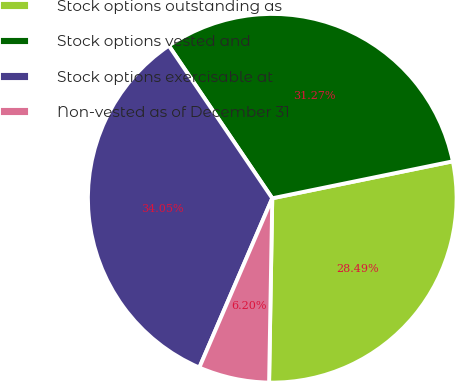Convert chart. <chart><loc_0><loc_0><loc_500><loc_500><pie_chart><fcel>Stock options outstanding as<fcel>Stock options vested and<fcel>Stock options exercisable at<fcel>Non-vested as of December 31<nl><fcel>28.49%<fcel>31.27%<fcel>34.05%<fcel>6.2%<nl></chart> 